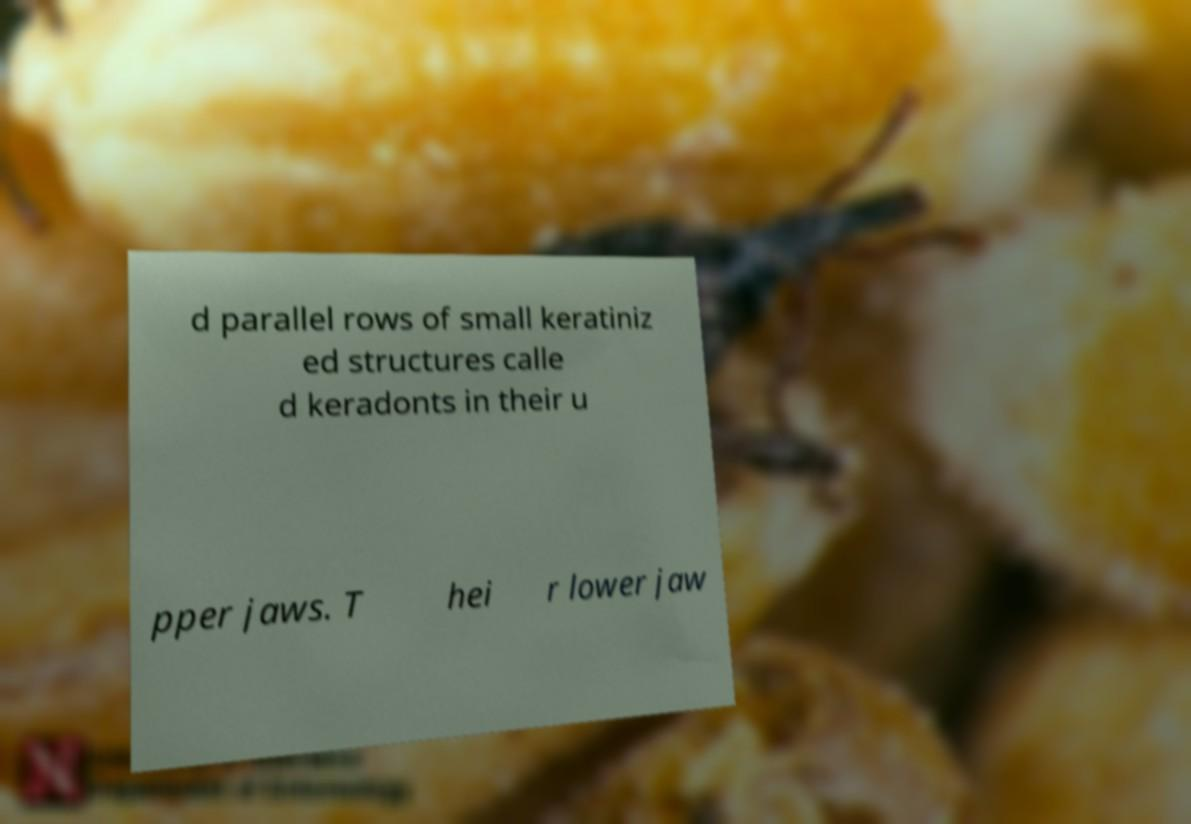Can you read and provide the text displayed in the image?This photo seems to have some interesting text. Can you extract and type it out for me? d parallel rows of small keratiniz ed structures calle d keradonts in their u pper jaws. T hei r lower jaw 